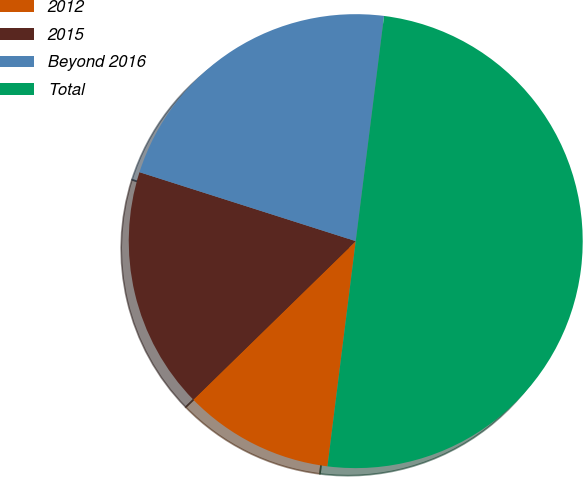Convert chart. <chart><loc_0><loc_0><loc_500><loc_500><pie_chart><fcel>2012<fcel>2015<fcel>Beyond 2016<fcel>Total<nl><fcel>10.71%<fcel>17.22%<fcel>22.08%<fcel>50.0%<nl></chart> 